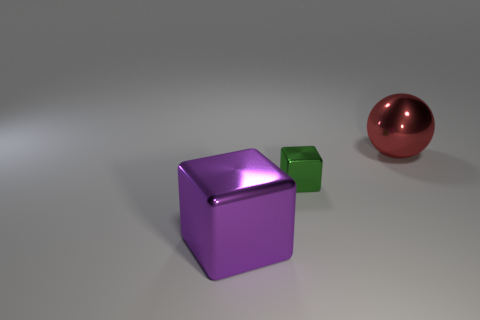What number of green objects are either tiny metal cubes or big spheres?
Keep it short and to the point. 1. What number of things are either metallic spheres or things that are to the left of the large red metal ball?
Offer a terse response. 3. What is the material of the block that is on the right side of the purple thing?
Offer a very short reply. Metal. There is a red metal thing that is the same size as the purple metallic object; what is its shape?
Offer a very short reply. Sphere. Is there another large thing that has the same shape as the green metallic thing?
Your answer should be compact. Yes. Is the tiny green block made of the same material as the big object to the left of the green thing?
Provide a short and direct response. Yes. There is a big object that is behind the big metallic thing to the left of the metal sphere; what is its material?
Ensure brevity in your answer.  Metal. Is the number of objects left of the tiny green metallic thing greater than the number of tiny yellow spheres?
Make the answer very short. Yes. Is there a big red cylinder?
Your answer should be very brief. No. What is the color of the big object that is behind the purple thing?
Your answer should be very brief. Red. 